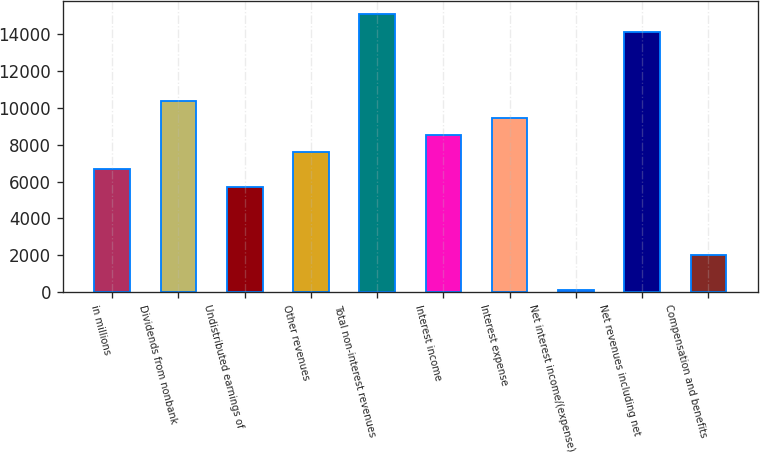Convert chart. <chart><loc_0><loc_0><loc_500><loc_500><bar_chart><fcel>in millions<fcel>Dividends from nonbank<fcel>Undistributed earnings of<fcel>Other revenues<fcel>Total non-interest revenues<fcel>Interest income<fcel>Interest expense<fcel>Net interest income/(expense)<fcel>Net revenues including net<fcel>Compensation and benefits<nl><fcel>6663.6<fcel>10406.8<fcel>5727.8<fcel>7599.4<fcel>15085.8<fcel>8535.2<fcel>9471<fcel>113<fcel>14150<fcel>1984.6<nl></chart> 